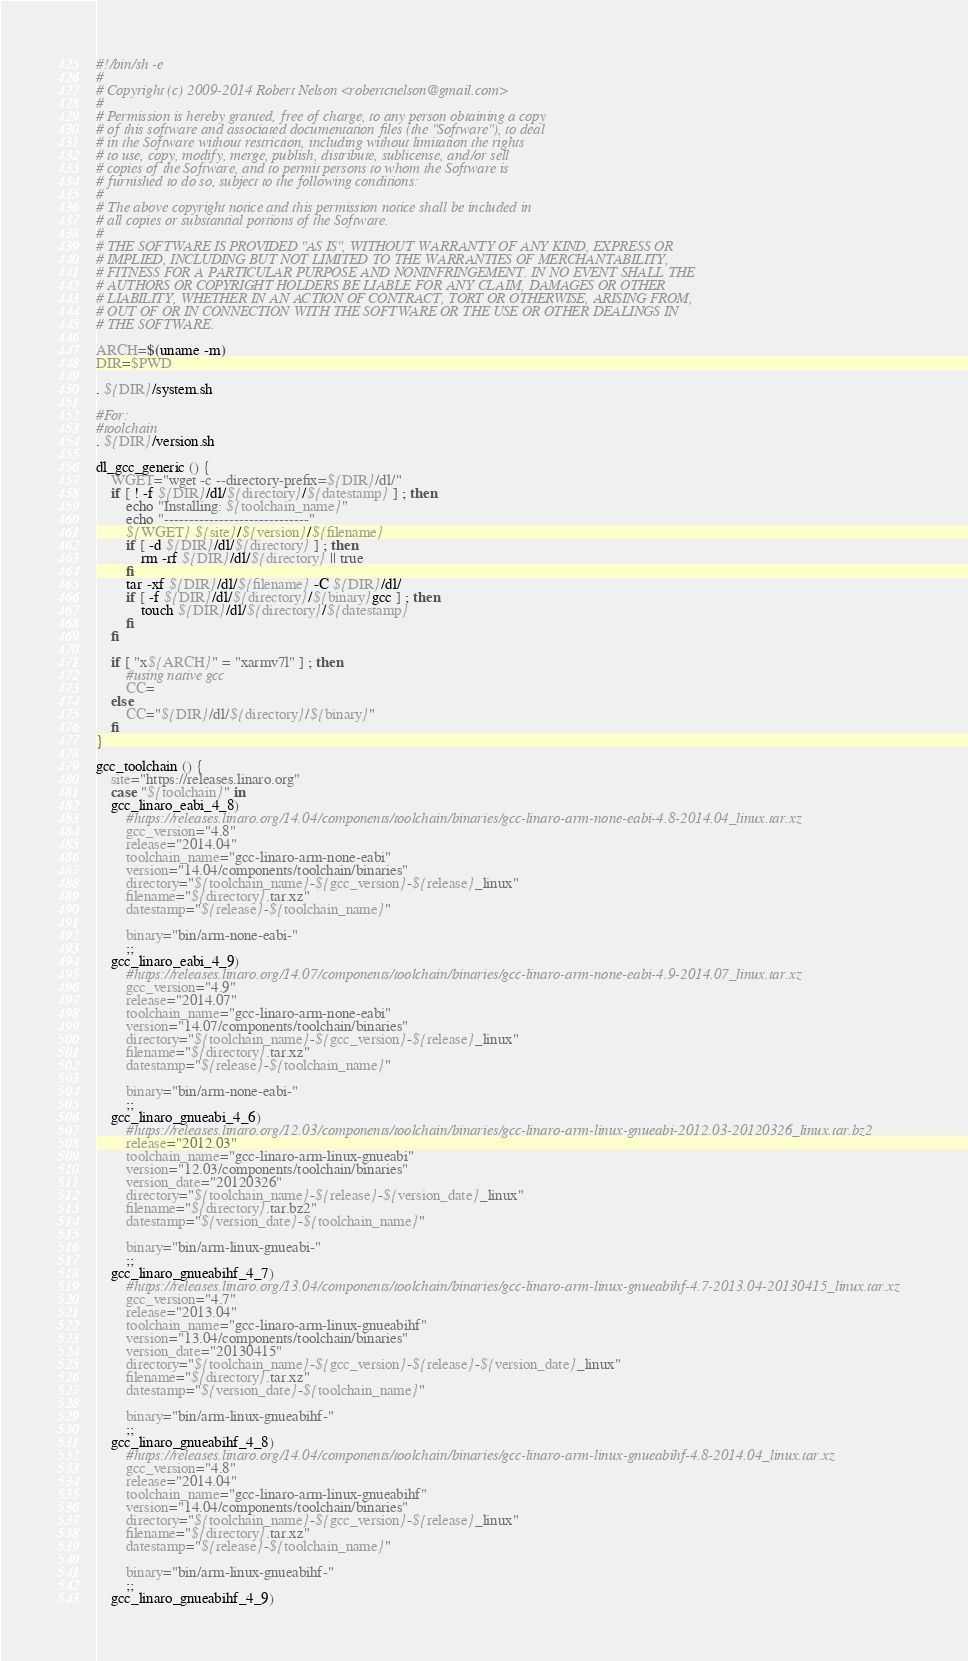Convert code to text. <code><loc_0><loc_0><loc_500><loc_500><_Bash_>#!/bin/sh -e
#
# Copyright (c) 2009-2014 Robert Nelson <robertcnelson@gmail.com>
#
# Permission is hereby granted, free of charge, to any person obtaining a copy
# of this software and associated documentation files (the "Software"), to deal
# in the Software without restriction, including without limitation the rights
# to use, copy, modify, merge, publish, distribute, sublicense, and/or sell
# copies of the Software, and to permit persons to whom the Software is
# furnished to do so, subject to the following conditions:
#
# The above copyright notice and this permission notice shall be included in
# all copies or substantial portions of the Software.
#
# THE SOFTWARE IS PROVIDED "AS IS", WITHOUT WARRANTY OF ANY KIND, EXPRESS OR
# IMPLIED, INCLUDING BUT NOT LIMITED TO THE WARRANTIES OF MERCHANTABILITY,
# FITNESS FOR A PARTICULAR PURPOSE AND NONINFRINGEMENT. IN NO EVENT SHALL THE
# AUTHORS OR COPYRIGHT HOLDERS BE LIABLE FOR ANY CLAIM, DAMAGES OR OTHER
# LIABILITY, WHETHER IN AN ACTION OF CONTRACT, TORT OR OTHERWISE, ARISING FROM,
# OUT OF OR IN CONNECTION WITH THE SOFTWARE OR THE USE OR OTHER DEALINGS IN
# THE SOFTWARE.

ARCH=$(uname -m)
DIR=$PWD

. ${DIR}/system.sh

#For:
#toolchain
. ${DIR}/version.sh

dl_gcc_generic () {
	WGET="wget -c --directory-prefix=${DIR}/dl/"
	if [ ! -f ${DIR}/dl/${directory}/${datestamp} ] ; then
		echo "Installing: ${toolchain_name}"
		echo "-----------------------------"
		${WGET} ${site}/${version}/${filename}
		if [ -d ${DIR}/dl/${directory} ] ; then
			rm -rf ${DIR}/dl/${directory} || true
		fi
		tar -xf ${DIR}/dl/${filename} -C ${DIR}/dl/
		if [ -f ${DIR}/dl/${directory}/${binary}gcc ] ; then
			touch ${DIR}/dl/${directory}/${datestamp}
		fi
	fi

	if [ "x${ARCH}" = "xarmv7l" ] ; then
		#using native gcc
		CC=
	else
		CC="${DIR}/dl/${directory}/${binary}"
	fi
}

gcc_toolchain () {
	site="https://releases.linaro.org"
	case "${toolchain}" in
	gcc_linaro_eabi_4_8)
		#https://releases.linaro.org/14.04/components/toolchain/binaries/gcc-linaro-arm-none-eabi-4.8-2014.04_linux.tar.xz
		gcc_version="4.8"
		release="2014.04"
		toolchain_name="gcc-linaro-arm-none-eabi"
		version="14.04/components/toolchain/binaries"
		directory="${toolchain_name}-${gcc_version}-${release}_linux"
		filename="${directory}.tar.xz"
		datestamp="${release}-${toolchain_name}"

		binary="bin/arm-none-eabi-"
		;;
	gcc_linaro_eabi_4_9)
		#https://releases.linaro.org/14.07/components/toolchain/binaries/gcc-linaro-arm-none-eabi-4.9-2014.07_linux.tar.xz
		gcc_version="4.9"
		release="2014.07"
		toolchain_name="gcc-linaro-arm-none-eabi"
		version="14.07/components/toolchain/binaries"
		directory="${toolchain_name}-${gcc_version}-${release}_linux"
		filename="${directory}.tar.xz"
		datestamp="${release}-${toolchain_name}"

		binary="bin/arm-none-eabi-"
		;;
	gcc_linaro_gnueabi_4_6)
		#https://releases.linaro.org/12.03/components/toolchain/binaries/gcc-linaro-arm-linux-gnueabi-2012.03-20120326_linux.tar.bz2
		release="2012.03"
		toolchain_name="gcc-linaro-arm-linux-gnueabi"
		version="12.03/components/toolchain/binaries"
		version_date="20120326"
		directory="${toolchain_name}-${release}-${version_date}_linux"
		filename="${directory}.tar.bz2"
		datestamp="${version_date}-${toolchain_name}"

		binary="bin/arm-linux-gnueabi-"
		;;
	gcc_linaro_gnueabihf_4_7)
		#https://releases.linaro.org/13.04/components/toolchain/binaries/gcc-linaro-arm-linux-gnueabihf-4.7-2013.04-20130415_linux.tar.xz
		gcc_version="4.7"
		release="2013.04"
		toolchain_name="gcc-linaro-arm-linux-gnueabihf"
		version="13.04/components/toolchain/binaries"
		version_date="20130415"
		directory="${toolchain_name}-${gcc_version}-${release}-${version_date}_linux"
		filename="${directory}.tar.xz"
		datestamp="${version_date}-${toolchain_name}"

		binary="bin/arm-linux-gnueabihf-"
		;;
	gcc_linaro_gnueabihf_4_8)
		#https://releases.linaro.org/14.04/components/toolchain/binaries/gcc-linaro-arm-linux-gnueabihf-4.8-2014.04_linux.tar.xz
		gcc_version="4.8"
		release="2014.04"
		toolchain_name="gcc-linaro-arm-linux-gnueabihf"
		version="14.04/components/toolchain/binaries"
		directory="${toolchain_name}-${gcc_version}-${release}_linux"
		filename="${directory}.tar.xz"
		datestamp="${release}-${toolchain_name}"

		binary="bin/arm-linux-gnueabihf-"
		;;
	gcc_linaro_gnueabihf_4_9)</code> 